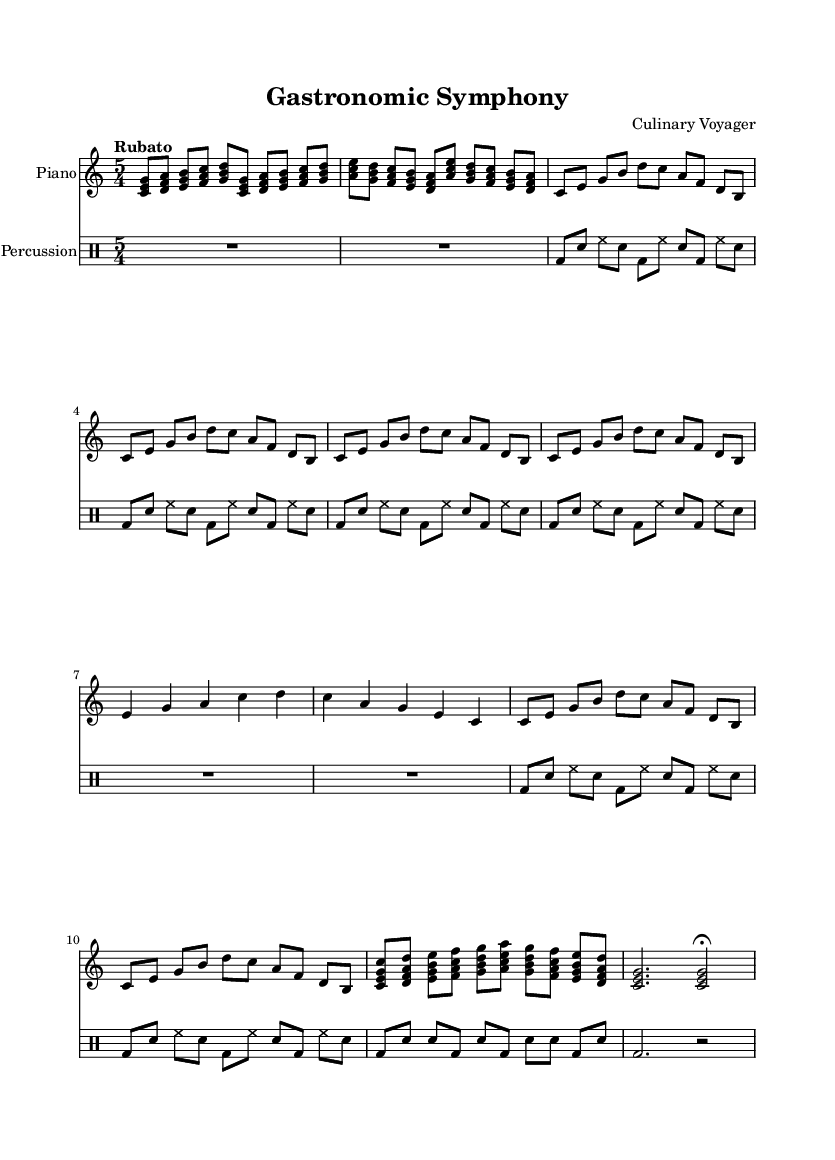What is the time signature of this music? The time signature is found at the beginning of the score and is written as 5/4, indicating that there are five beats in each measure and a quarter note receives one beat.
Answer: 5/4 What is the tempo marking given for this composition? The tempo marking appears at the start of the score. It states "Rubato," which indicates a flexible tempo, allowing expressive timing in performance.
Answer: Rubato How many sections are there in the piano part? By analyzing the structure of the piano part, we can see distinct sections: Introduction, Main Theme, Interlude, Variation, Climax, and Coda. This totals six sections.
Answer: 6 What type of percussion instruments are used in this composition? In the percussion part, we can identify specific notations such as "bd" for bass drum, "sn" for snare drum, and "hh" for hi-hat, showing the variety of instruments involved.
Answer: Bass drum, snare drum, hi-hat What is the main theme's rhythmic pattern in the piano part? By observing the repeated motif in the Main Theme section, we note that it consists of eighth notes, following a specific pitch sequence with consistent rhythms.
Answer: Eighth notes How is the climax of the piece structured? The climax section appears to have denser and more varied rhythmic activity compared to earlier sections. Analyzing the notation reveals pairs of notes played in a sustained manner, creating tension and excitement.
Answer: Denser rhythmic activity 